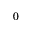Convert formula to latex. <formula><loc_0><loc_0><loc_500><loc_500>0</formula> 